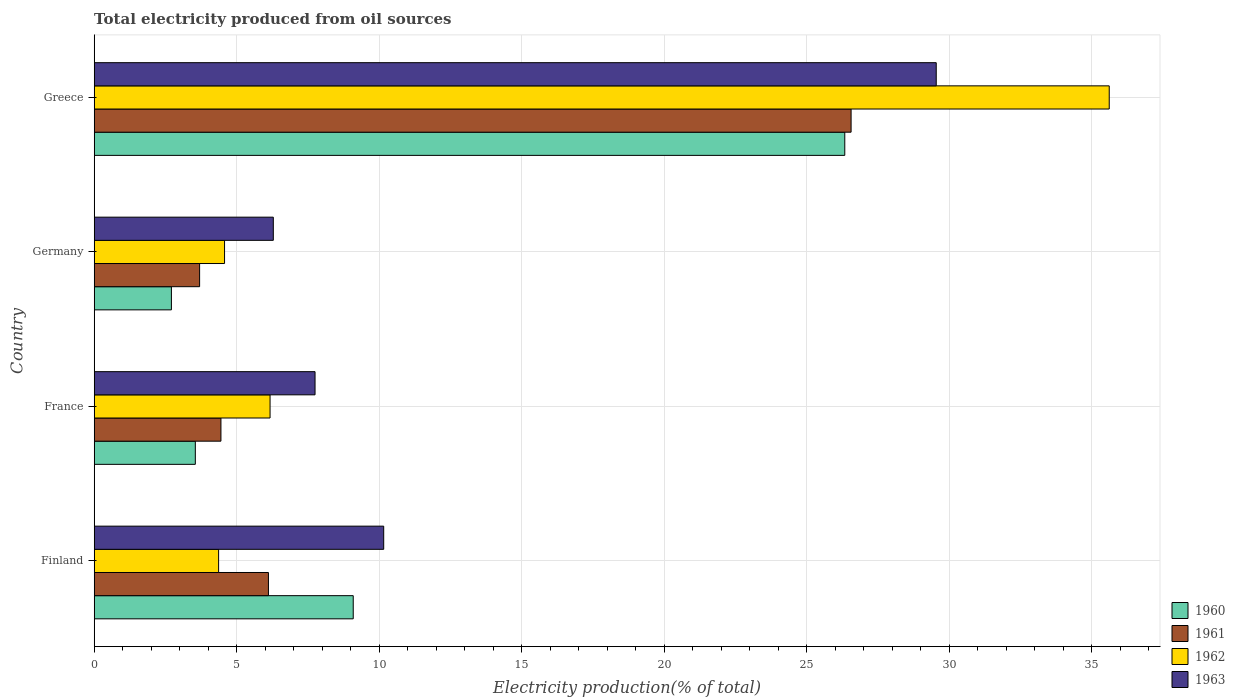Are the number of bars per tick equal to the number of legend labels?
Keep it short and to the point. Yes. Are the number of bars on each tick of the Y-axis equal?
Offer a very short reply. Yes. How many bars are there on the 3rd tick from the top?
Offer a very short reply. 4. What is the label of the 3rd group of bars from the top?
Ensure brevity in your answer.  France. In how many cases, is the number of bars for a given country not equal to the number of legend labels?
Ensure brevity in your answer.  0. What is the total electricity produced in 1963 in Greece?
Provide a short and direct response. 29.54. Across all countries, what is the maximum total electricity produced in 1961?
Your answer should be compact. 26.55. Across all countries, what is the minimum total electricity produced in 1960?
Offer a very short reply. 2.71. In which country was the total electricity produced in 1960 maximum?
Your response must be concise. Greece. What is the total total electricity produced in 1960 in the graph?
Your answer should be compact. 41.68. What is the difference between the total electricity produced in 1963 in Finland and that in Germany?
Your answer should be compact. 3.87. What is the difference between the total electricity produced in 1962 in Greece and the total electricity produced in 1960 in Finland?
Your response must be concise. 26.52. What is the average total electricity produced in 1963 per country?
Keep it short and to the point. 13.43. What is the difference between the total electricity produced in 1960 and total electricity produced in 1963 in France?
Offer a terse response. -4.2. What is the ratio of the total electricity produced in 1962 in France to that in Greece?
Provide a short and direct response. 0.17. Is the difference between the total electricity produced in 1960 in France and Germany greater than the difference between the total electricity produced in 1963 in France and Germany?
Your response must be concise. No. What is the difference between the highest and the second highest total electricity produced in 1961?
Provide a short and direct response. 20.44. What is the difference between the highest and the lowest total electricity produced in 1962?
Your answer should be compact. 31.25. In how many countries, is the total electricity produced in 1960 greater than the average total electricity produced in 1960 taken over all countries?
Give a very brief answer. 1. Is the sum of the total electricity produced in 1961 in Finland and Germany greater than the maximum total electricity produced in 1963 across all countries?
Offer a terse response. No. Is it the case that in every country, the sum of the total electricity produced in 1961 and total electricity produced in 1963 is greater than the sum of total electricity produced in 1962 and total electricity produced in 1960?
Keep it short and to the point. No. What does the 4th bar from the top in Greece represents?
Your answer should be very brief. 1960. What does the 4th bar from the bottom in France represents?
Give a very brief answer. 1963. Is it the case that in every country, the sum of the total electricity produced in 1962 and total electricity produced in 1961 is greater than the total electricity produced in 1963?
Offer a terse response. Yes. Does the graph contain any zero values?
Offer a terse response. No. Does the graph contain grids?
Make the answer very short. Yes. What is the title of the graph?
Your answer should be very brief. Total electricity produced from oil sources. What is the label or title of the X-axis?
Your answer should be compact. Electricity production(% of total). What is the Electricity production(% of total) in 1960 in Finland?
Keep it short and to the point. 9.09. What is the Electricity production(% of total) in 1961 in Finland?
Make the answer very short. 6.11. What is the Electricity production(% of total) of 1962 in Finland?
Make the answer very short. 4.36. What is the Electricity production(% of total) in 1963 in Finland?
Your answer should be very brief. 10.16. What is the Electricity production(% of total) in 1960 in France?
Your response must be concise. 3.55. What is the Electricity production(% of total) of 1961 in France?
Provide a succinct answer. 4.45. What is the Electricity production(% of total) of 1962 in France?
Your answer should be compact. 6.17. What is the Electricity production(% of total) of 1963 in France?
Give a very brief answer. 7.75. What is the Electricity production(% of total) in 1960 in Germany?
Provide a short and direct response. 2.71. What is the Electricity production(% of total) in 1961 in Germany?
Provide a short and direct response. 3.7. What is the Electricity production(% of total) of 1962 in Germany?
Provide a succinct answer. 4.57. What is the Electricity production(% of total) of 1963 in Germany?
Your answer should be compact. 6.28. What is the Electricity production(% of total) of 1960 in Greece?
Make the answer very short. 26.33. What is the Electricity production(% of total) in 1961 in Greece?
Offer a terse response. 26.55. What is the Electricity production(% of total) of 1962 in Greece?
Offer a terse response. 35.61. What is the Electricity production(% of total) in 1963 in Greece?
Provide a short and direct response. 29.54. Across all countries, what is the maximum Electricity production(% of total) in 1960?
Provide a short and direct response. 26.33. Across all countries, what is the maximum Electricity production(% of total) of 1961?
Provide a succinct answer. 26.55. Across all countries, what is the maximum Electricity production(% of total) in 1962?
Your answer should be very brief. 35.61. Across all countries, what is the maximum Electricity production(% of total) of 1963?
Your answer should be very brief. 29.54. Across all countries, what is the minimum Electricity production(% of total) of 1960?
Provide a succinct answer. 2.71. Across all countries, what is the minimum Electricity production(% of total) in 1961?
Your response must be concise. 3.7. Across all countries, what is the minimum Electricity production(% of total) in 1962?
Your answer should be compact. 4.36. Across all countries, what is the minimum Electricity production(% of total) in 1963?
Offer a very short reply. 6.28. What is the total Electricity production(% of total) of 1960 in the graph?
Your answer should be compact. 41.68. What is the total Electricity production(% of total) of 1961 in the graph?
Give a very brief answer. 40.81. What is the total Electricity production(% of total) in 1962 in the graph?
Make the answer very short. 50.72. What is the total Electricity production(% of total) of 1963 in the graph?
Your answer should be very brief. 53.73. What is the difference between the Electricity production(% of total) in 1960 in Finland and that in France?
Ensure brevity in your answer.  5.54. What is the difference between the Electricity production(% of total) of 1961 in Finland and that in France?
Ensure brevity in your answer.  1.67. What is the difference between the Electricity production(% of total) in 1962 in Finland and that in France?
Your answer should be very brief. -1.8. What is the difference between the Electricity production(% of total) in 1963 in Finland and that in France?
Your answer should be compact. 2.41. What is the difference between the Electricity production(% of total) in 1960 in Finland and that in Germany?
Provide a succinct answer. 6.38. What is the difference between the Electricity production(% of total) of 1961 in Finland and that in Germany?
Your response must be concise. 2.41. What is the difference between the Electricity production(% of total) of 1962 in Finland and that in Germany?
Your answer should be very brief. -0.21. What is the difference between the Electricity production(% of total) in 1963 in Finland and that in Germany?
Provide a short and direct response. 3.87. What is the difference between the Electricity production(% of total) in 1960 in Finland and that in Greece?
Make the answer very short. -17.24. What is the difference between the Electricity production(% of total) in 1961 in Finland and that in Greece?
Offer a terse response. -20.44. What is the difference between the Electricity production(% of total) of 1962 in Finland and that in Greece?
Your answer should be compact. -31.25. What is the difference between the Electricity production(% of total) in 1963 in Finland and that in Greece?
Offer a terse response. -19.38. What is the difference between the Electricity production(% of total) of 1960 in France and that in Germany?
Give a very brief answer. 0.84. What is the difference between the Electricity production(% of total) in 1961 in France and that in Germany?
Provide a succinct answer. 0.75. What is the difference between the Electricity production(% of total) in 1962 in France and that in Germany?
Give a very brief answer. 1.6. What is the difference between the Electricity production(% of total) in 1963 in France and that in Germany?
Give a very brief answer. 1.46. What is the difference between the Electricity production(% of total) in 1960 in France and that in Greece?
Keep it short and to the point. -22.78. What is the difference between the Electricity production(% of total) of 1961 in France and that in Greece?
Your response must be concise. -22.11. What is the difference between the Electricity production(% of total) of 1962 in France and that in Greece?
Offer a terse response. -29.44. What is the difference between the Electricity production(% of total) of 1963 in France and that in Greece?
Keep it short and to the point. -21.79. What is the difference between the Electricity production(% of total) in 1960 in Germany and that in Greece?
Keep it short and to the point. -23.62. What is the difference between the Electricity production(% of total) in 1961 in Germany and that in Greece?
Ensure brevity in your answer.  -22.86. What is the difference between the Electricity production(% of total) in 1962 in Germany and that in Greece?
Offer a terse response. -31.04. What is the difference between the Electricity production(% of total) in 1963 in Germany and that in Greece?
Make the answer very short. -23.26. What is the difference between the Electricity production(% of total) in 1960 in Finland and the Electricity production(% of total) in 1961 in France?
Offer a very short reply. 4.64. What is the difference between the Electricity production(% of total) in 1960 in Finland and the Electricity production(% of total) in 1962 in France?
Offer a very short reply. 2.92. What is the difference between the Electricity production(% of total) in 1960 in Finland and the Electricity production(% of total) in 1963 in France?
Provide a succinct answer. 1.34. What is the difference between the Electricity production(% of total) in 1961 in Finland and the Electricity production(% of total) in 1962 in France?
Provide a succinct answer. -0.06. What is the difference between the Electricity production(% of total) of 1961 in Finland and the Electricity production(% of total) of 1963 in France?
Offer a very short reply. -1.64. What is the difference between the Electricity production(% of total) of 1962 in Finland and the Electricity production(% of total) of 1963 in France?
Your response must be concise. -3.38. What is the difference between the Electricity production(% of total) in 1960 in Finland and the Electricity production(% of total) in 1961 in Germany?
Your answer should be very brief. 5.39. What is the difference between the Electricity production(% of total) of 1960 in Finland and the Electricity production(% of total) of 1962 in Germany?
Give a very brief answer. 4.51. What is the difference between the Electricity production(% of total) of 1960 in Finland and the Electricity production(% of total) of 1963 in Germany?
Your answer should be compact. 2.8. What is the difference between the Electricity production(% of total) in 1961 in Finland and the Electricity production(% of total) in 1962 in Germany?
Provide a short and direct response. 1.54. What is the difference between the Electricity production(% of total) of 1961 in Finland and the Electricity production(% of total) of 1963 in Germany?
Keep it short and to the point. -0.17. What is the difference between the Electricity production(% of total) in 1962 in Finland and the Electricity production(% of total) in 1963 in Germany?
Offer a terse response. -1.92. What is the difference between the Electricity production(% of total) in 1960 in Finland and the Electricity production(% of total) in 1961 in Greece?
Your response must be concise. -17.47. What is the difference between the Electricity production(% of total) of 1960 in Finland and the Electricity production(% of total) of 1962 in Greece?
Keep it short and to the point. -26.52. What is the difference between the Electricity production(% of total) in 1960 in Finland and the Electricity production(% of total) in 1963 in Greece?
Give a very brief answer. -20.45. What is the difference between the Electricity production(% of total) in 1961 in Finland and the Electricity production(% of total) in 1962 in Greece?
Provide a short and direct response. -29.5. What is the difference between the Electricity production(% of total) in 1961 in Finland and the Electricity production(% of total) in 1963 in Greece?
Provide a succinct answer. -23.43. What is the difference between the Electricity production(% of total) of 1962 in Finland and the Electricity production(% of total) of 1963 in Greece?
Make the answer very short. -25.18. What is the difference between the Electricity production(% of total) in 1960 in France and the Electricity production(% of total) in 1961 in Germany?
Make the answer very short. -0.15. What is the difference between the Electricity production(% of total) in 1960 in France and the Electricity production(% of total) in 1962 in Germany?
Offer a terse response. -1.02. What is the difference between the Electricity production(% of total) in 1960 in France and the Electricity production(% of total) in 1963 in Germany?
Offer a terse response. -2.74. What is the difference between the Electricity production(% of total) in 1961 in France and the Electricity production(% of total) in 1962 in Germany?
Ensure brevity in your answer.  -0.13. What is the difference between the Electricity production(% of total) of 1961 in France and the Electricity production(% of total) of 1963 in Germany?
Your answer should be compact. -1.84. What is the difference between the Electricity production(% of total) of 1962 in France and the Electricity production(% of total) of 1963 in Germany?
Offer a very short reply. -0.11. What is the difference between the Electricity production(% of total) of 1960 in France and the Electricity production(% of total) of 1961 in Greece?
Offer a very short reply. -23.01. What is the difference between the Electricity production(% of total) of 1960 in France and the Electricity production(% of total) of 1962 in Greece?
Keep it short and to the point. -32.06. What is the difference between the Electricity production(% of total) of 1960 in France and the Electricity production(% of total) of 1963 in Greece?
Your response must be concise. -25.99. What is the difference between the Electricity production(% of total) of 1961 in France and the Electricity production(% of total) of 1962 in Greece?
Your answer should be very brief. -31.16. What is the difference between the Electricity production(% of total) of 1961 in France and the Electricity production(% of total) of 1963 in Greece?
Keep it short and to the point. -25.09. What is the difference between the Electricity production(% of total) of 1962 in France and the Electricity production(% of total) of 1963 in Greece?
Your answer should be compact. -23.37. What is the difference between the Electricity production(% of total) of 1960 in Germany and the Electricity production(% of total) of 1961 in Greece?
Make the answer very short. -23.85. What is the difference between the Electricity production(% of total) in 1960 in Germany and the Electricity production(% of total) in 1962 in Greece?
Your answer should be compact. -32.9. What is the difference between the Electricity production(% of total) of 1960 in Germany and the Electricity production(% of total) of 1963 in Greece?
Ensure brevity in your answer.  -26.83. What is the difference between the Electricity production(% of total) of 1961 in Germany and the Electricity production(% of total) of 1962 in Greece?
Make the answer very short. -31.91. What is the difference between the Electricity production(% of total) of 1961 in Germany and the Electricity production(% of total) of 1963 in Greece?
Your answer should be compact. -25.84. What is the difference between the Electricity production(% of total) in 1962 in Germany and the Electricity production(% of total) in 1963 in Greece?
Offer a very short reply. -24.97. What is the average Electricity production(% of total) of 1960 per country?
Ensure brevity in your answer.  10.42. What is the average Electricity production(% of total) of 1961 per country?
Your response must be concise. 10.2. What is the average Electricity production(% of total) of 1962 per country?
Offer a terse response. 12.68. What is the average Electricity production(% of total) in 1963 per country?
Your answer should be very brief. 13.43. What is the difference between the Electricity production(% of total) in 1960 and Electricity production(% of total) in 1961 in Finland?
Give a very brief answer. 2.98. What is the difference between the Electricity production(% of total) in 1960 and Electricity production(% of total) in 1962 in Finland?
Offer a terse response. 4.72. What is the difference between the Electricity production(% of total) in 1960 and Electricity production(% of total) in 1963 in Finland?
Give a very brief answer. -1.07. What is the difference between the Electricity production(% of total) in 1961 and Electricity production(% of total) in 1962 in Finland?
Provide a succinct answer. 1.75. What is the difference between the Electricity production(% of total) of 1961 and Electricity production(% of total) of 1963 in Finland?
Give a very brief answer. -4.04. What is the difference between the Electricity production(% of total) in 1962 and Electricity production(% of total) in 1963 in Finland?
Ensure brevity in your answer.  -5.79. What is the difference between the Electricity production(% of total) of 1960 and Electricity production(% of total) of 1961 in France?
Provide a short and direct response. -0.9. What is the difference between the Electricity production(% of total) of 1960 and Electricity production(% of total) of 1962 in France?
Your response must be concise. -2.62. What is the difference between the Electricity production(% of total) of 1960 and Electricity production(% of total) of 1963 in France?
Keep it short and to the point. -4.2. What is the difference between the Electricity production(% of total) in 1961 and Electricity production(% of total) in 1962 in France?
Offer a very short reply. -1.72. What is the difference between the Electricity production(% of total) in 1961 and Electricity production(% of total) in 1963 in France?
Ensure brevity in your answer.  -3.3. What is the difference between the Electricity production(% of total) in 1962 and Electricity production(% of total) in 1963 in France?
Ensure brevity in your answer.  -1.58. What is the difference between the Electricity production(% of total) of 1960 and Electricity production(% of total) of 1961 in Germany?
Offer a terse response. -0.99. What is the difference between the Electricity production(% of total) of 1960 and Electricity production(% of total) of 1962 in Germany?
Offer a terse response. -1.86. What is the difference between the Electricity production(% of total) in 1960 and Electricity production(% of total) in 1963 in Germany?
Give a very brief answer. -3.58. What is the difference between the Electricity production(% of total) in 1961 and Electricity production(% of total) in 1962 in Germany?
Provide a succinct answer. -0.87. What is the difference between the Electricity production(% of total) in 1961 and Electricity production(% of total) in 1963 in Germany?
Ensure brevity in your answer.  -2.59. What is the difference between the Electricity production(% of total) of 1962 and Electricity production(% of total) of 1963 in Germany?
Your answer should be compact. -1.71. What is the difference between the Electricity production(% of total) of 1960 and Electricity production(% of total) of 1961 in Greece?
Your answer should be very brief. -0.22. What is the difference between the Electricity production(% of total) of 1960 and Electricity production(% of total) of 1962 in Greece?
Provide a succinct answer. -9.28. What is the difference between the Electricity production(% of total) in 1960 and Electricity production(% of total) in 1963 in Greece?
Your response must be concise. -3.21. What is the difference between the Electricity production(% of total) in 1961 and Electricity production(% of total) in 1962 in Greece?
Your answer should be compact. -9.06. What is the difference between the Electricity production(% of total) in 1961 and Electricity production(% of total) in 1963 in Greece?
Keep it short and to the point. -2.99. What is the difference between the Electricity production(% of total) of 1962 and Electricity production(% of total) of 1963 in Greece?
Offer a very short reply. 6.07. What is the ratio of the Electricity production(% of total) in 1960 in Finland to that in France?
Ensure brevity in your answer.  2.56. What is the ratio of the Electricity production(% of total) in 1961 in Finland to that in France?
Offer a very short reply. 1.37. What is the ratio of the Electricity production(% of total) of 1962 in Finland to that in France?
Give a very brief answer. 0.71. What is the ratio of the Electricity production(% of total) of 1963 in Finland to that in France?
Provide a short and direct response. 1.31. What is the ratio of the Electricity production(% of total) in 1960 in Finland to that in Germany?
Your response must be concise. 3.36. What is the ratio of the Electricity production(% of total) of 1961 in Finland to that in Germany?
Your response must be concise. 1.65. What is the ratio of the Electricity production(% of total) in 1962 in Finland to that in Germany?
Provide a succinct answer. 0.95. What is the ratio of the Electricity production(% of total) in 1963 in Finland to that in Germany?
Provide a succinct answer. 1.62. What is the ratio of the Electricity production(% of total) in 1960 in Finland to that in Greece?
Offer a very short reply. 0.35. What is the ratio of the Electricity production(% of total) of 1961 in Finland to that in Greece?
Offer a very short reply. 0.23. What is the ratio of the Electricity production(% of total) in 1962 in Finland to that in Greece?
Provide a short and direct response. 0.12. What is the ratio of the Electricity production(% of total) of 1963 in Finland to that in Greece?
Give a very brief answer. 0.34. What is the ratio of the Electricity production(% of total) of 1960 in France to that in Germany?
Offer a terse response. 1.31. What is the ratio of the Electricity production(% of total) in 1961 in France to that in Germany?
Ensure brevity in your answer.  1.2. What is the ratio of the Electricity production(% of total) of 1962 in France to that in Germany?
Make the answer very short. 1.35. What is the ratio of the Electricity production(% of total) of 1963 in France to that in Germany?
Keep it short and to the point. 1.23. What is the ratio of the Electricity production(% of total) in 1960 in France to that in Greece?
Ensure brevity in your answer.  0.13. What is the ratio of the Electricity production(% of total) of 1961 in France to that in Greece?
Give a very brief answer. 0.17. What is the ratio of the Electricity production(% of total) in 1962 in France to that in Greece?
Your answer should be very brief. 0.17. What is the ratio of the Electricity production(% of total) in 1963 in France to that in Greece?
Make the answer very short. 0.26. What is the ratio of the Electricity production(% of total) of 1960 in Germany to that in Greece?
Provide a short and direct response. 0.1. What is the ratio of the Electricity production(% of total) in 1961 in Germany to that in Greece?
Offer a terse response. 0.14. What is the ratio of the Electricity production(% of total) in 1962 in Germany to that in Greece?
Offer a very short reply. 0.13. What is the ratio of the Electricity production(% of total) of 1963 in Germany to that in Greece?
Provide a succinct answer. 0.21. What is the difference between the highest and the second highest Electricity production(% of total) in 1960?
Provide a succinct answer. 17.24. What is the difference between the highest and the second highest Electricity production(% of total) in 1961?
Your answer should be compact. 20.44. What is the difference between the highest and the second highest Electricity production(% of total) in 1962?
Your response must be concise. 29.44. What is the difference between the highest and the second highest Electricity production(% of total) of 1963?
Your answer should be compact. 19.38. What is the difference between the highest and the lowest Electricity production(% of total) in 1960?
Your response must be concise. 23.62. What is the difference between the highest and the lowest Electricity production(% of total) in 1961?
Make the answer very short. 22.86. What is the difference between the highest and the lowest Electricity production(% of total) of 1962?
Your response must be concise. 31.25. What is the difference between the highest and the lowest Electricity production(% of total) in 1963?
Make the answer very short. 23.26. 